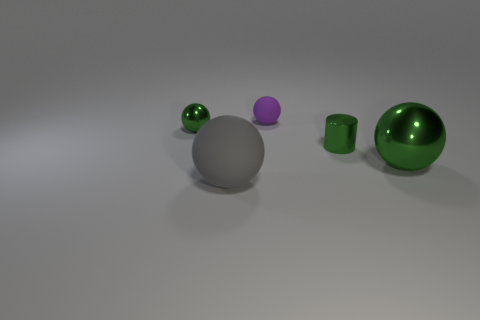There is a rubber thing that is in front of the large green metal object; is it the same shape as the small purple rubber object?
Your answer should be compact. Yes. There is a small object that is the same color as the small metal ball; what is it made of?
Make the answer very short. Metal. There is a thing left of the thing in front of the big metal object; what shape is it?
Your response must be concise. Sphere. The small cylinder that is made of the same material as the big green ball is what color?
Ensure brevity in your answer.  Green. There is a sphere in front of the large green metal sphere in front of the small metal thing that is on the left side of the gray matte thing; how big is it?
Offer a very short reply. Large. The other small matte thing that is the same shape as the gray rubber thing is what color?
Ensure brevity in your answer.  Purple. Are there any green spheres that are behind the metallic sphere that is on the right side of the tiny ball to the right of the small green ball?
Offer a terse response. Yes. Does the tiny purple rubber object have the same shape as the big matte object?
Your answer should be compact. Yes. There is a metallic ball that is to the left of the matte thing that is behind the green metal sphere that is left of the green metallic cylinder; what is its color?
Your answer should be compact. Green. Is the purple matte object the same size as the metallic cylinder?
Provide a short and direct response. Yes. 